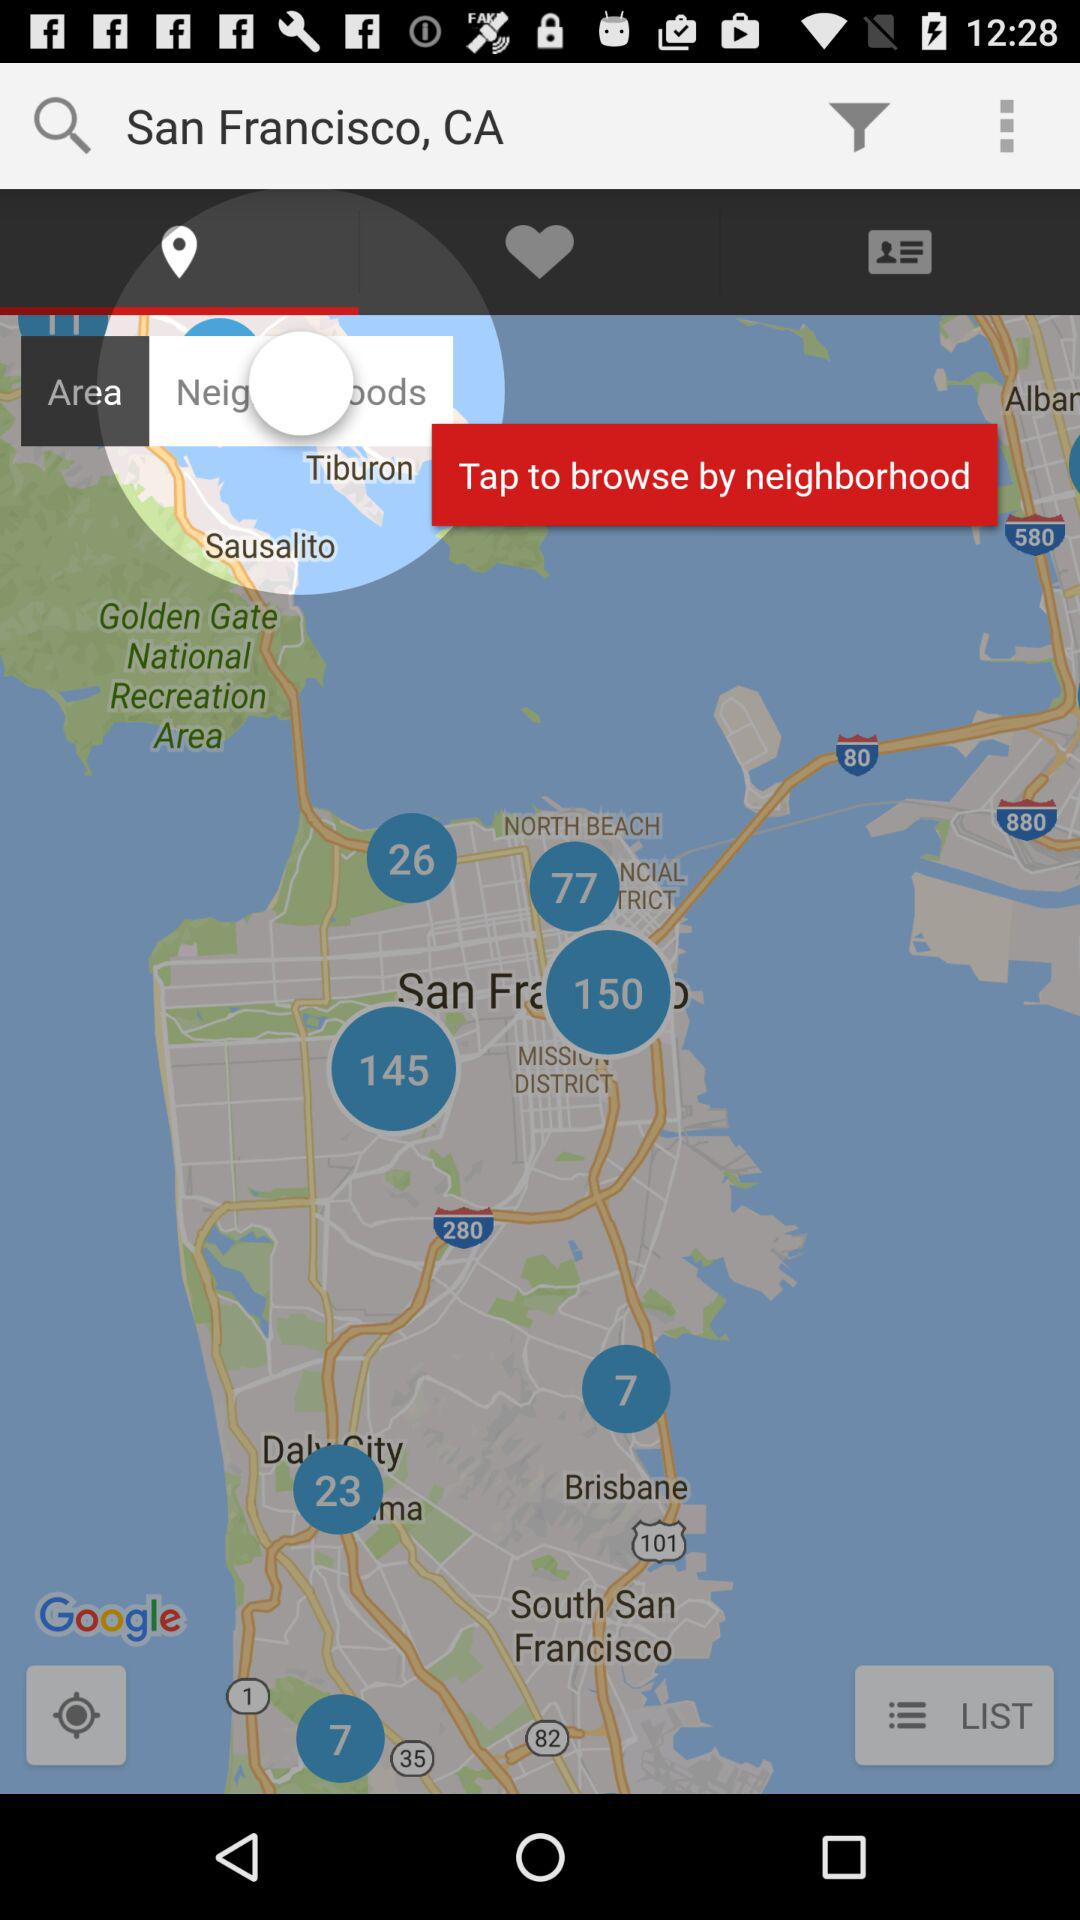Which tab has been selected? The tab that has been selected is "Location". 